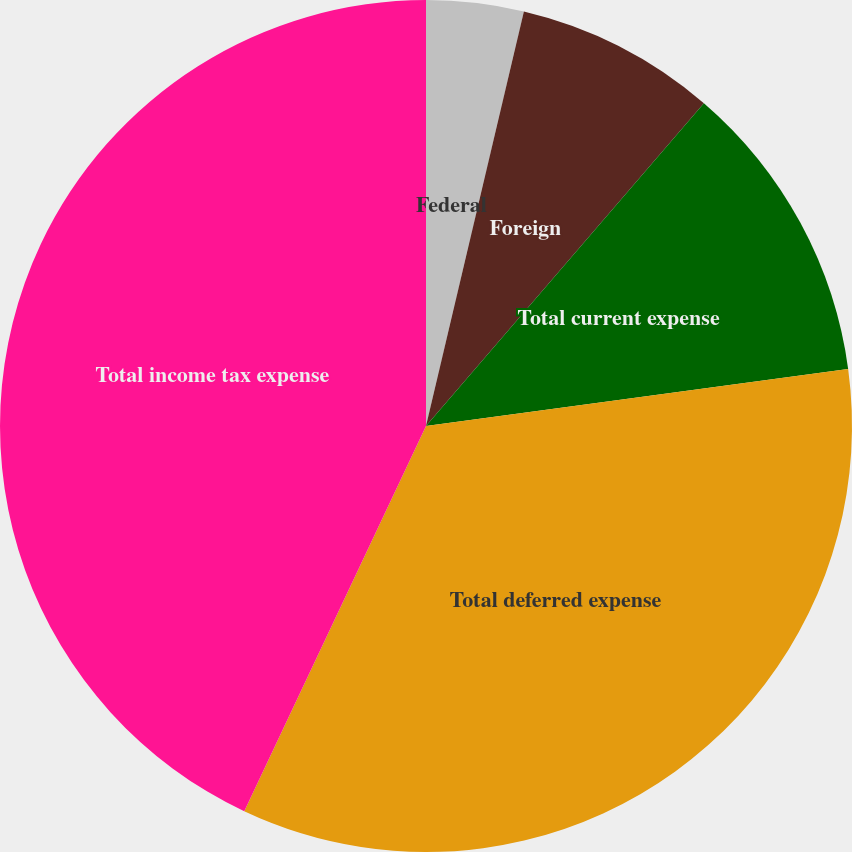<chart> <loc_0><loc_0><loc_500><loc_500><pie_chart><fcel>Federal<fcel>Foreign<fcel>Total current expense<fcel>Total deferred expense<fcel>Total income tax expense<nl><fcel>3.69%<fcel>7.62%<fcel>11.55%<fcel>34.15%<fcel>42.98%<nl></chart> 